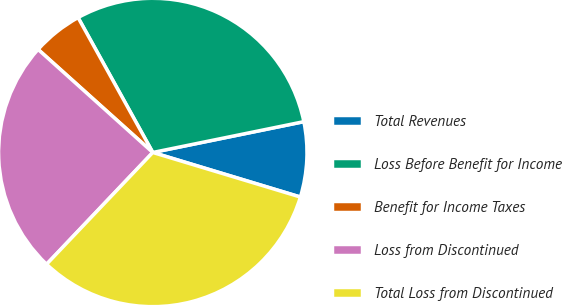Convert chart. <chart><loc_0><loc_0><loc_500><loc_500><pie_chart><fcel>Total Revenues<fcel>Loss Before Benefit for Income<fcel>Benefit for Income Taxes<fcel>Loss from Discontinued<fcel>Total Loss from Discontinued<nl><fcel>7.87%<fcel>29.85%<fcel>5.3%<fcel>24.56%<fcel>32.43%<nl></chart> 